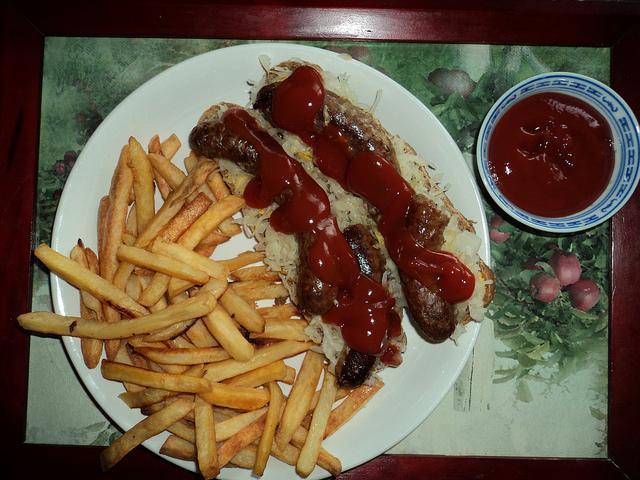How many hot dogs are in the picture?
Give a very brief answer. 2. 